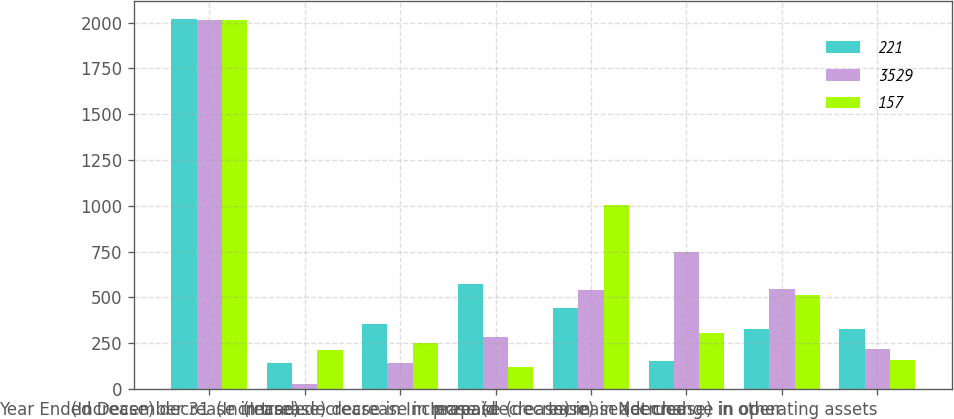Convert chart to OTSL. <chart><loc_0><loc_0><loc_500><loc_500><stacked_bar_chart><ecel><fcel>Year Ended December 31<fcel>(Increase) decrease in trade<fcel>(Increase) decrease in<fcel>(Increase) decrease in prepaid<fcel>Increase (decrease) in<fcel>Increase (decrease) in accrued<fcel>Increase (decrease) in other<fcel>Net change in operating assets<nl><fcel>221<fcel>2017<fcel>141<fcel>355<fcel>571<fcel>445<fcel>153<fcel>330.5<fcel>330.5<nl><fcel>3529<fcel>2016<fcel>28<fcel>142<fcel>283<fcel>540<fcel>750<fcel>544<fcel>221<nl><fcel>157<fcel>2015<fcel>212<fcel>250<fcel>123<fcel>1004<fcel>306<fcel>516<fcel>157<nl></chart> 